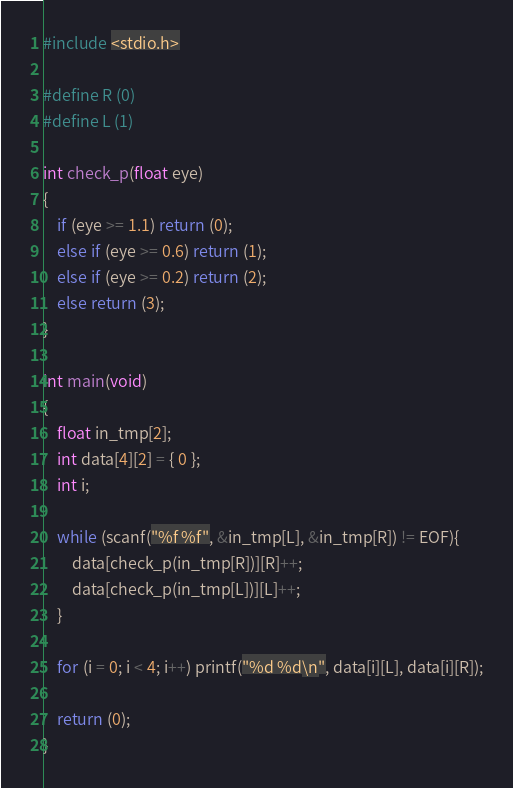<code> <loc_0><loc_0><loc_500><loc_500><_C_>#include <stdio.h>

#define R (0)
#define L (1)

int check_p(float eye)
{
	if (eye >= 1.1) return (0);
	else if (eye >= 0.6) return (1);
	else if (eye >= 0.2) return (2);
	else return (3);
}

int main(void)
{
	float in_tmp[2];
	int data[4][2] = { 0 };
	int i;
	
	while (scanf("%f %f", &in_tmp[L], &in_tmp[R]) != EOF){
		data[check_p(in_tmp[R])][R]++;
		data[check_p(in_tmp[L])][L]++;
	}
	
	for (i = 0; i < 4; i++) printf("%d %d\n", data[i][L], data[i][R]);
	
	return (0);
}</code> 